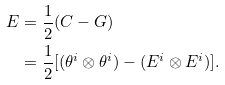<formula> <loc_0><loc_0><loc_500><loc_500>E & = \frac { 1 } { 2 } ( C - G ) \\ & = \frac { 1 } { 2 } [ ( \theta ^ { i } \otimes \theta ^ { i } ) - ( E ^ { i } \otimes E ^ { i } ) ] .</formula> 